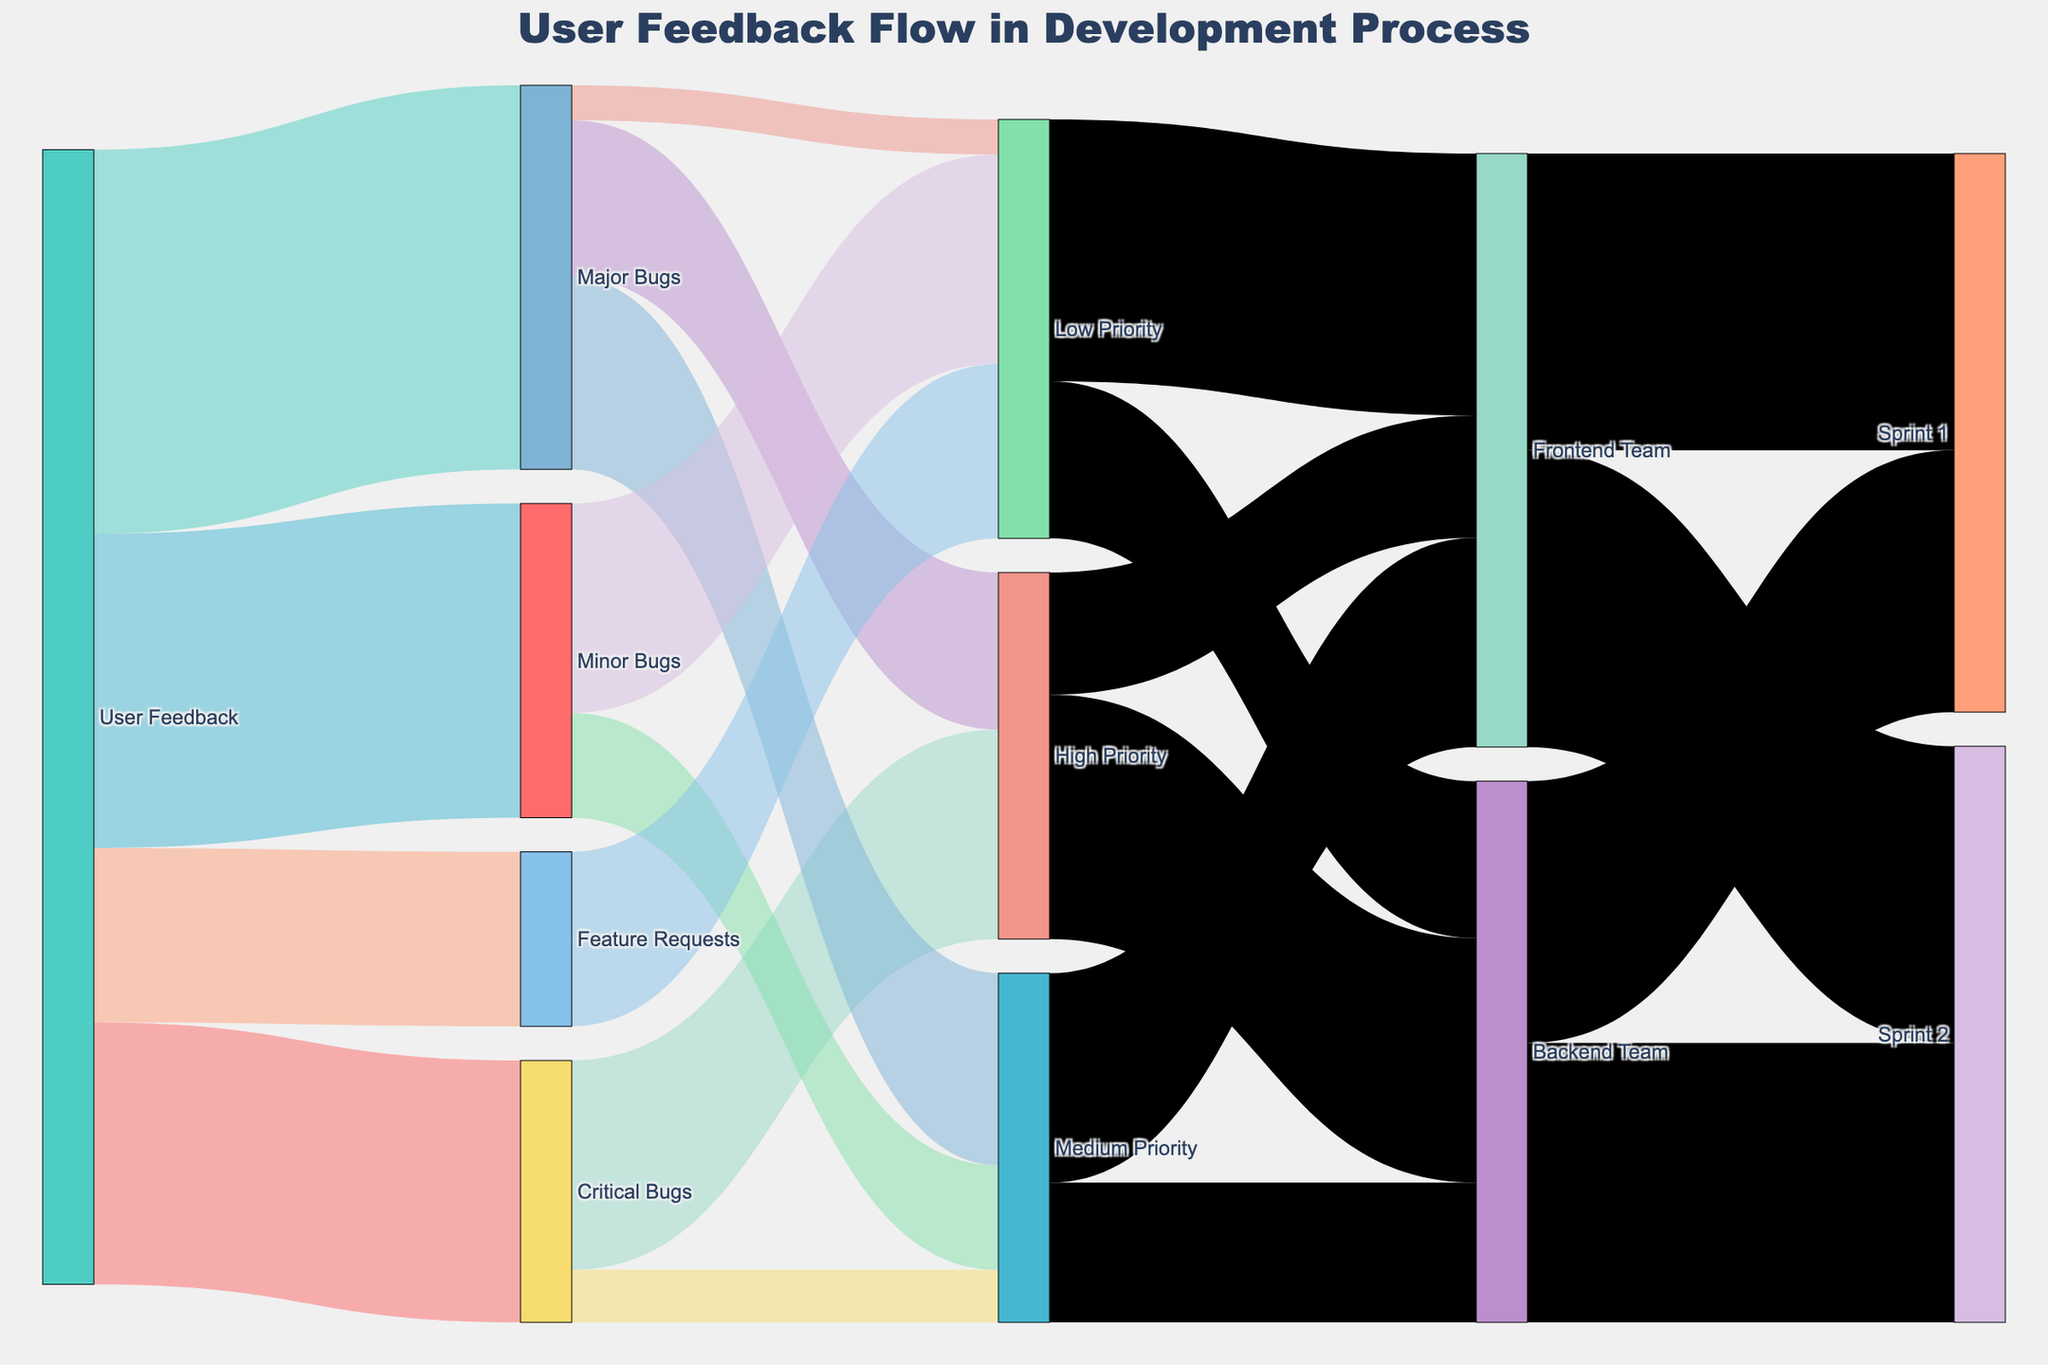What is the title of the figure? The title is typically located at the top center of the figure. In this case, it is "User Feedback Flow in Development Process" as specified in the layout configuration of the plot.
Answer: User Feedback Flow in Development Process What is the largest category of user feedback in terms of value? To determine the largest category, look at the values flowing from "User Feedback" to different categories. The values are 150 for Critical Bugs, 220 for Major Bugs, 180 for Minor Bugs, and 100 for Feature Requests. The largest value is 220 associated with "Major Bugs".
Answer: Major Bugs How many values flow into the "Backend Team"? To find this, check all links leading to "Backend Team". From High Priority: 140, Medium Priority: 80, Low Priority: 90. The total flow to "Backend Team" is 140 + 80 + 90 = 310.
Answer: 310 What is the difference between user feedback categorized as Major Bugs and Minor Bugs? Subtract the value of Minor Bugs from Major Bugs. Major Bugs have a value of 220 and Minor Bugs have a value of 180. So, the difference is 220 - 180 = 40.
Answer: 40 Which team handles more Medium Priority tasks? Compare the values flowing to "Backend Team" and "Frontend Team" from Medium Priority. Backend Team has a flow of 80, while Frontend Team has 120. Therefore, the Frontend Team handles more Medium Priority tasks.
Answer: Frontend Team How are Critical Bugs prioritized? Check the values flowing from "Critical Bugs" to different priority levels. The values are 120 to High Priority and 30 to Medium Priority. Therefore, Critical Bugs are mostly prioritized as High Priority.
Answer: High Priority How many items are categorized as Low Priority across all sources? Sum the values flowing into Low Priority. From Major Bugs: 20, from Minor Bugs: 120, and from Feature Requests: 100. The total is 20 + 120 + 100 = 240.
Answer: 240 Which team, Backend or Frontend, has more tasks in Sprint 1? Sum up tasks assigned to each team for Sprint 1. Backend Team: 150 tasks. Frontend Team: 170 tasks. Therefore, Frontend Team has more tasks in Sprint 1.
Answer: Frontend Team How many Critical Bugs are assigned to the High Priority? Look at the value from Critical Bugs to High Priority. The value is 120, indicating that 120 Critical Bugs are assigned to High Priority.
Answer: 120 